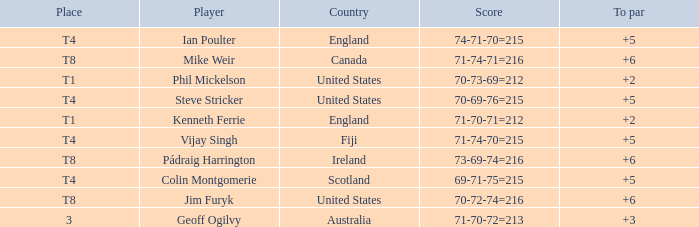Who had a score of 70-73-69=212? Phil Mickelson. 